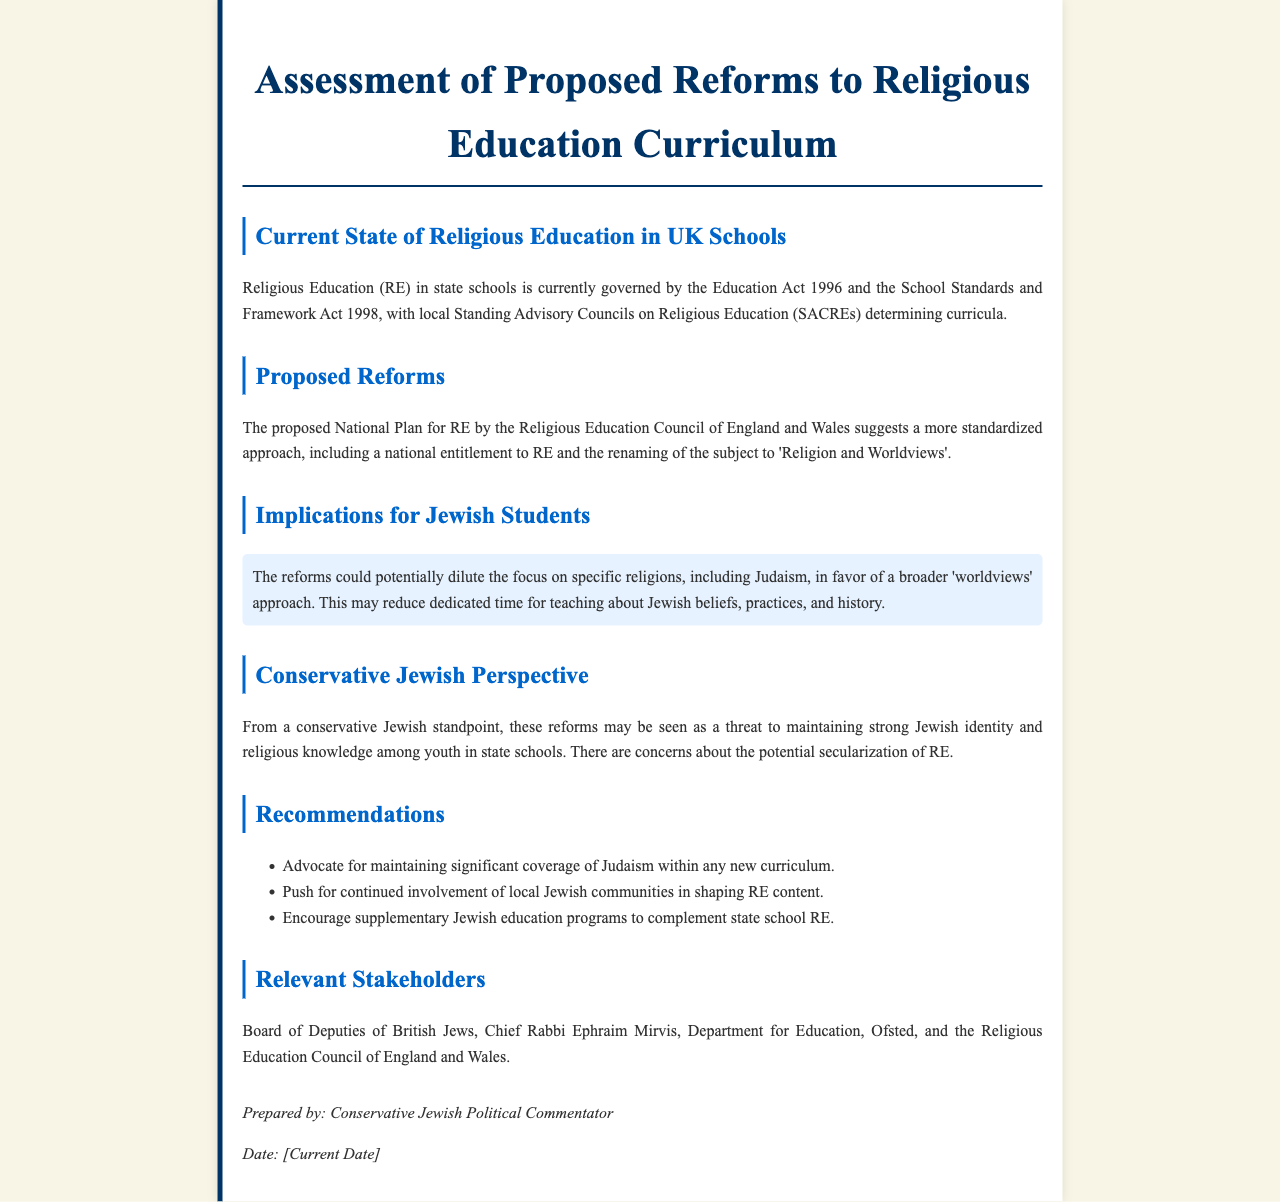What is the current governing legislation for Religious Education in UK schools? The current governing legislation for Religious Education in UK schools is the Education Act 1996 and the School Standards and Framework Act 1998.
Answer: Education Act 1996, School Standards and Framework Act 1998 What is the suggested new title for Religious Education? The suggested new title for Religious Education is 'Religion and Worldviews'.
Answer: Religion and Worldviews Which council determines the curricula for Religious Education? The local Standing Advisory Councils on Religious Education (SACREs) determine the curricula.
Answer: SACREs What potential effect do the reforms have on the teaching of Judaism? The reforms could potentially dilute the focus on specific religions, including Judaism.
Answer: Dilute the focus on specific religions What are recommended actions for Jewish students' education? Recommended actions include advocating for significant coverage of Judaism, community involvement, and supplementary education programs.
Answer: Advocate for maintaining significant coverage of Judaism Who are the relevant stakeholders mentioned in the document? The relevant stakeholders include the Board of Deputies of British Jews, Chief Rabbi Ephraim Mirvis, Department for Education, Ofsted, and Religious Education Council.
Answer: Board of Deputies of British Jews, Chief Rabbi Ephraim Mirvis, Department for Education, Ofsted, Religious Education Council What concern is raised regarding the potential impact of reforms? The concern raised is about the potential secularization of Religious Education.
Answer: Secularization of RE What is the perspective of conservative Jews on these reforms? The perspective of conservative Jews is that the reforms may threaten maintaining a strong Jewish identity.
Answer: Threaten strong Jewish identity 